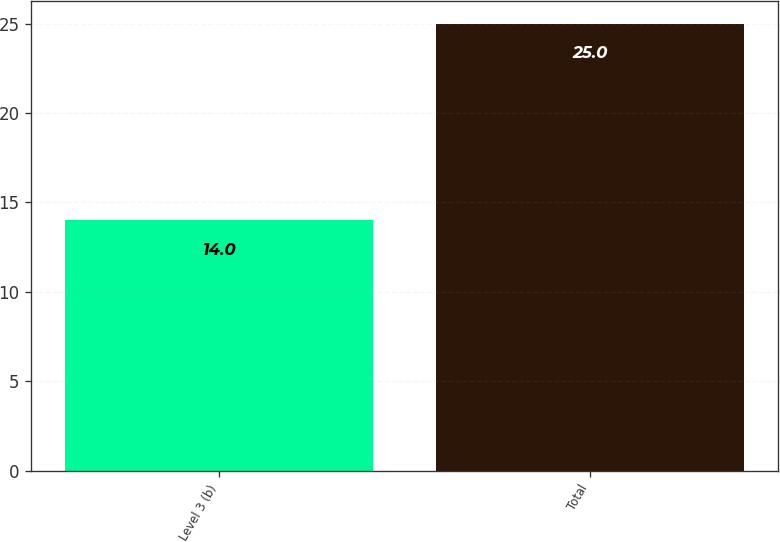<chart> <loc_0><loc_0><loc_500><loc_500><bar_chart><fcel>Level 3 (b)<fcel>Total<nl><fcel>14<fcel>25<nl></chart> 